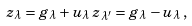<formula> <loc_0><loc_0><loc_500><loc_500>z _ { \lambda } = g _ { \lambda } + u _ { \lambda } \, z _ { \lambda ^ { \prime } } = g _ { \lambda } - u _ { \lambda } \, ,</formula> 